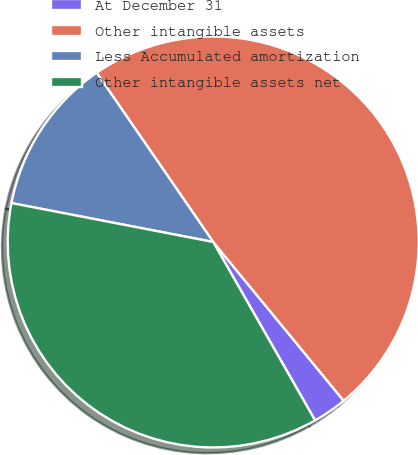Convert chart. <chart><loc_0><loc_0><loc_500><loc_500><pie_chart><fcel>At December 31<fcel>Other intangible assets<fcel>Less Accumulated amortization<fcel>Other intangible assets net<nl><fcel>2.69%<fcel>48.65%<fcel>12.37%<fcel>36.29%<nl></chart> 